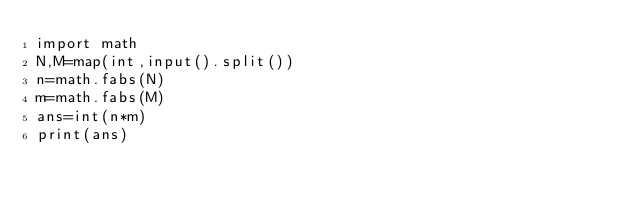Convert code to text. <code><loc_0><loc_0><loc_500><loc_500><_Python_>import math
N,M=map(int,input().split())
n=math.fabs(N)
m=math.fabs(M)
ans=int(n*m)
print(ans)
</code> 